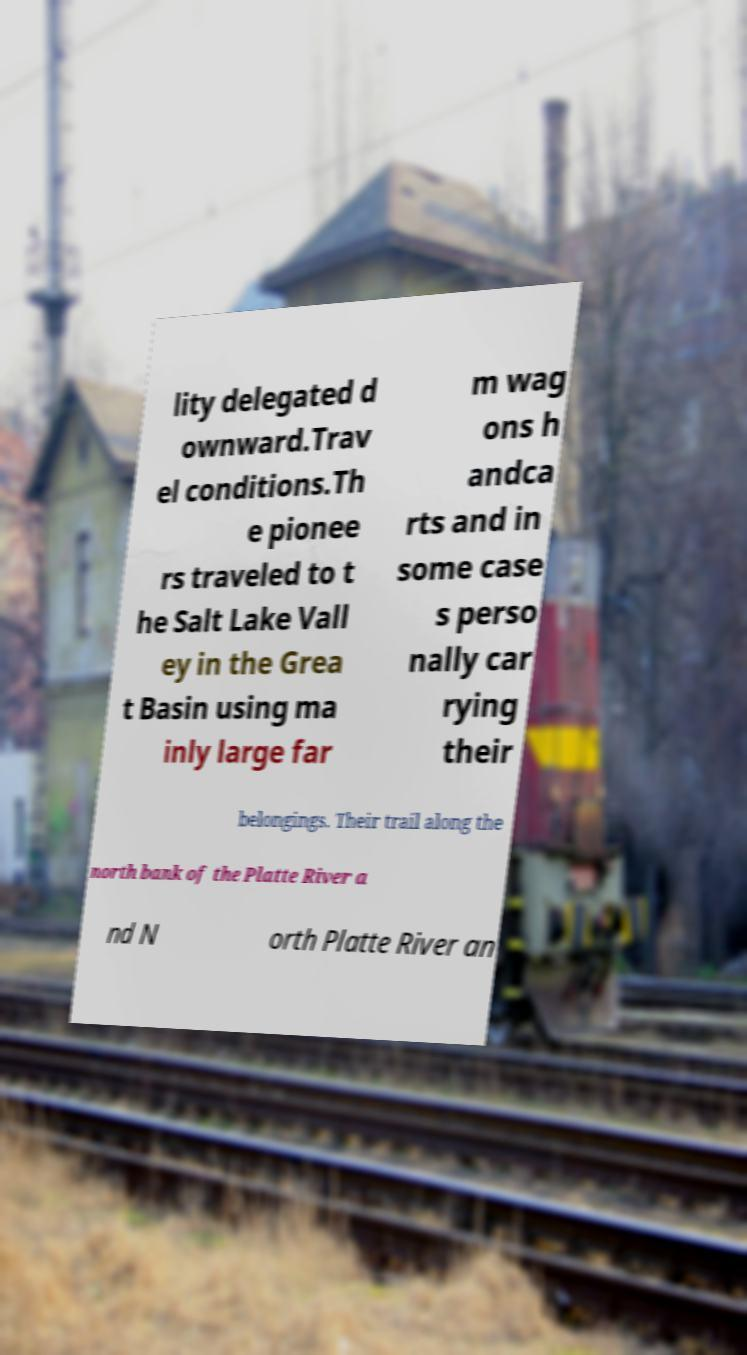Can you accurately transcribe the text from the provided image for me? lity delegated d ownward.Trav el conditions.Th e pionee rs traveled to t he Salt Lake Vall ey in the Grea t Basin using ma inly large far m wag ons h andca rts and in some case s perso nally car rying their belongings. Their trail along the north bank of the Platte River a nd N orth Platte River an 